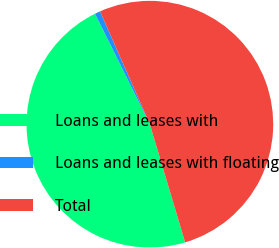Convert chart. <chart><loc_0><loc_0><loc_500><loc_500><pie_chart><fcel>Loans and leases with<fcel>Loans and leases with floating<fcel>Total<nl><fcel>47.28%<fcel>0.72%<fcel>52.0%<nl></chart> 